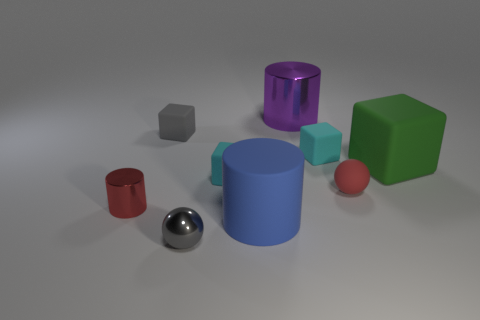Subtract all tiny rubber blocks. How many blocks are left? 1 Subtract all green cubes. How many cubes are left? 3 Add 1 small red spheres. How many objects exist? 10 Subtract 2 cubes. How many cubes are left? 2 Subtract all small cyan matte objects. Subtract all tiny cyan rubber things. How many objects are left? 5 Add 8 large green objects. How many large green objects are left? 9 Add 4 cyan rubber things. How many cyan rubber things exist? 6 Subtract 1 gray spheres. How many objects are left? 8 Subtract all blocks. How many objects are left? 5 Subtract all brown balls. Subtract all gray blocks. How many balls are left? 2 